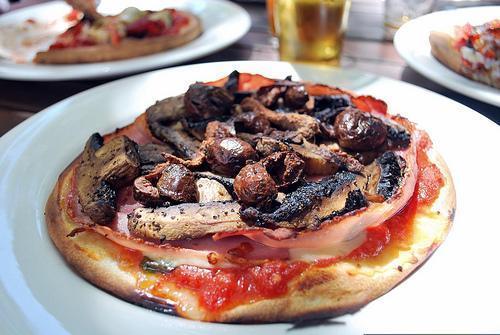How many dishes?
Give a very brief answer. 3. 